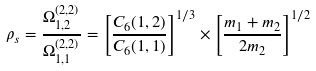Convert formula to latex. <formula><loc_0><loc_0><loc_500><loc_500>\rho _ { s } = \frac { \Omega _ { 1 , 2 } ^ { \left ( 2 , 2 \right ) } } { \Omega _ { 1 , 1 } ^ { \left ( 2 , 2 \right ) } } = \left [ \frac { C _ { 6 } ( 1 , 2 ) } { C _ { 6 } ( 1 , 1 ) } \right ] ^ { 1 / 3 } \times \left [ \frac { m _ { 1 } + m _ { 2 } } { 2 m _ { 2 } } \right ] ^ { 1 / 2 }</formula> 